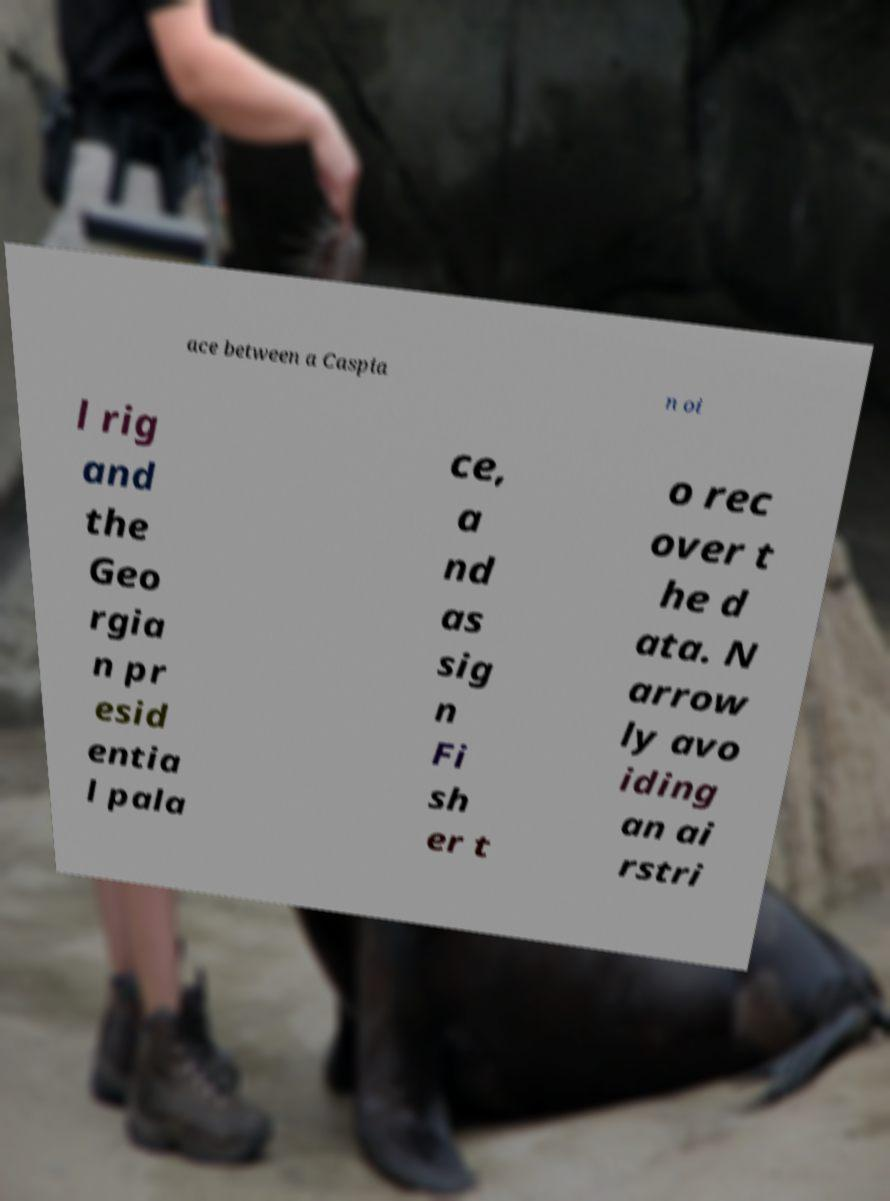Please identify and transcribe the text found in this image. ace between a Caspia n oi l rig and the Geo rgia n pr esid entia l pala ce, a nd as sig n Fi sh er t o rec over t he d ata. N arrow ly avo iding an ai rstri 